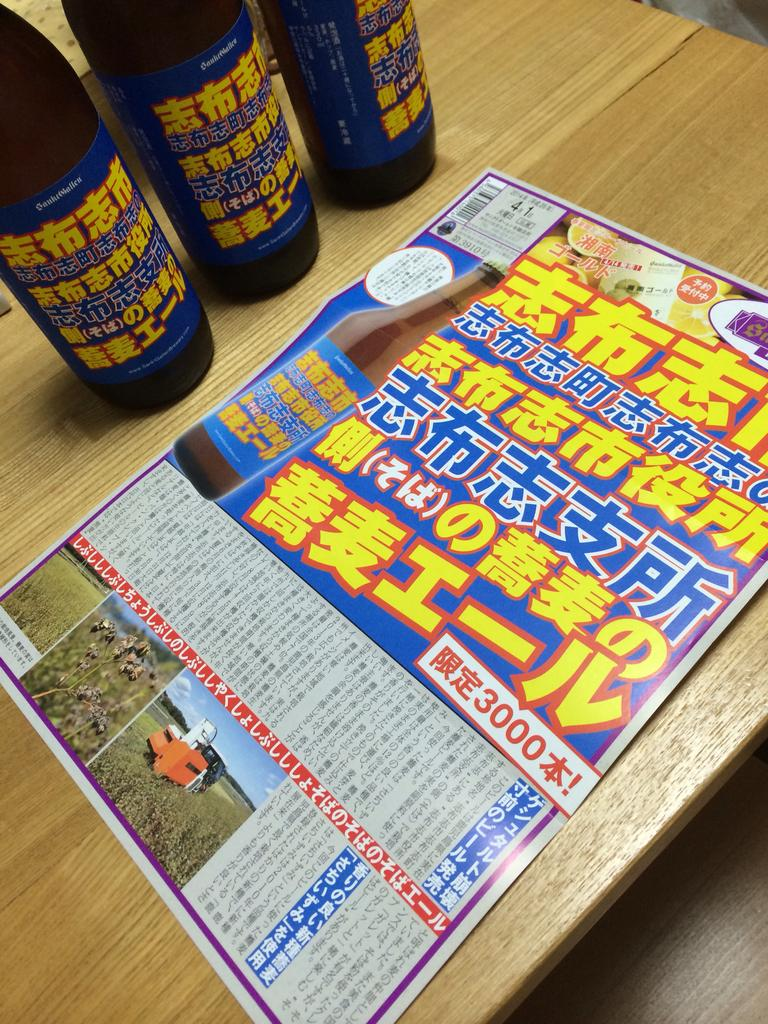Provide a one-sentence caption for the provided image. 3 bottles in background and a page showing ad for same bottle with 3000 showing in a box on the page. 